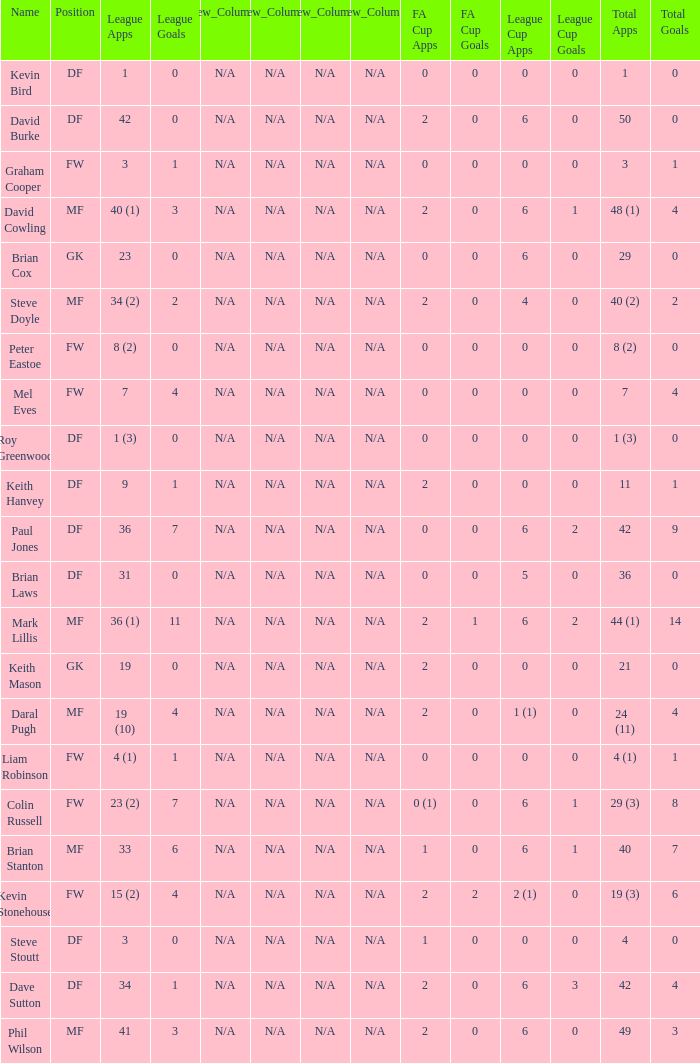What is the most total goals for a player having 0 FA Cup goals and 41 League appearances? 3.0. 